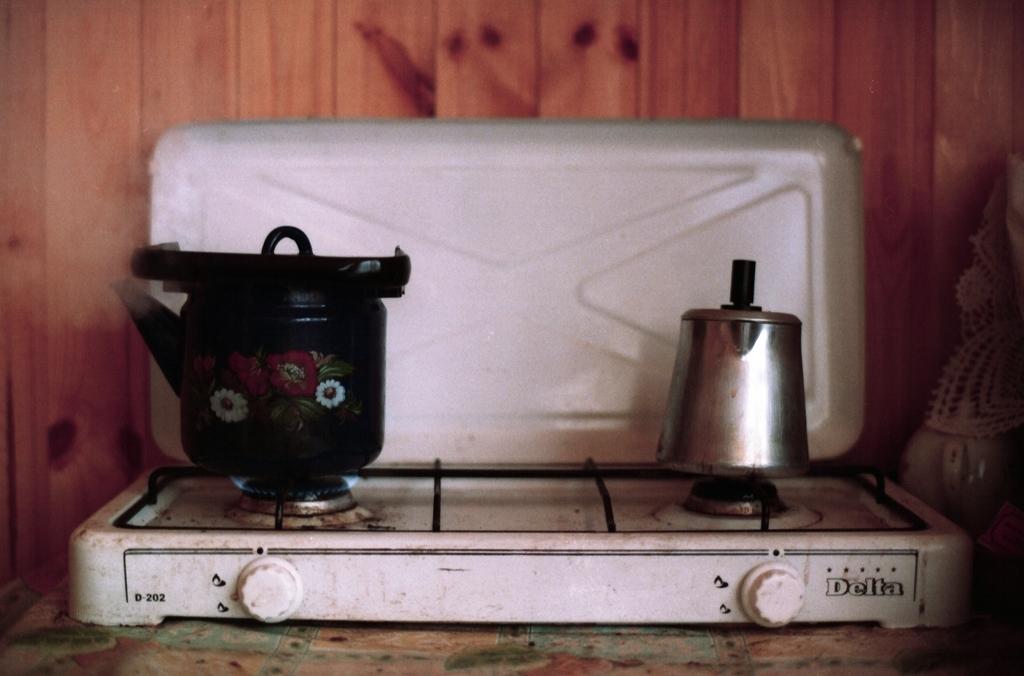What brand is this stove?
Provide a short and direct response. Delta. 